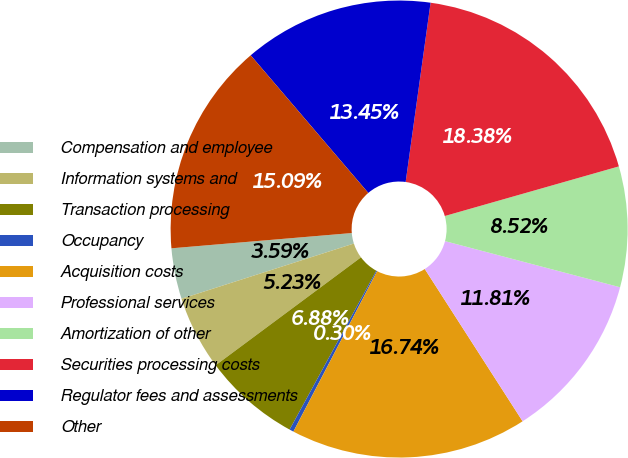<chart> <loc_0><loc_0><loc_500><loc_500><pie_chart><fcel>Compensation and employee<fcel>Information systems and<fcel>Transaction processing<fcel>Occupancy<fcel>Acquisition costs<fcel>Professional services<fcel>Amortization of other<fcel>Securities processing costs<fcel>Regulator fees and assessments<fcel>Other<nl><fcel>3.59%<fcel>5.23%<fcel>6.88%<fcel>0.3%<fcel>16.74%<fcel>11.81%<fcel>8.52%<fcel>18.38%<fcel>13.45%<fcel>15.09%<nl></chart> 